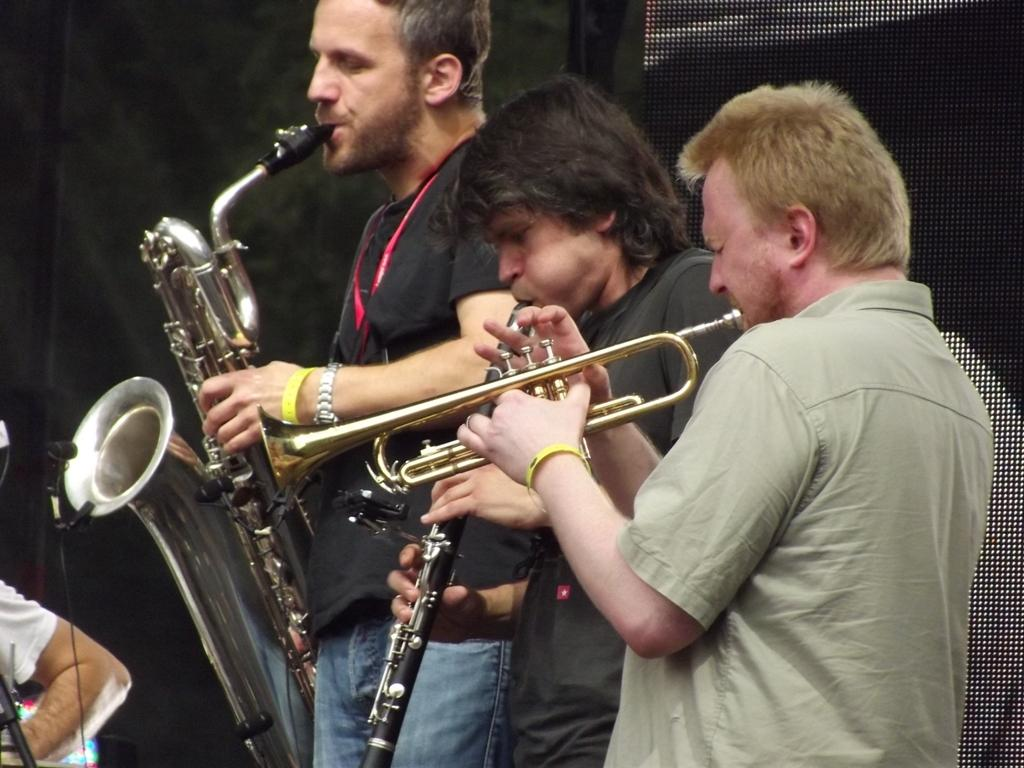How many people are in the image? There are three men in the image. What are the men doing in the image? The men are standing and playing different music instruments. Can you describe the actions of the men in the image? The men are standing and playing music instruments, which suggests they might be in a band or performing. How many horses are visible in the image? There are no horses present in the image. What type of garden can be seen in the background of the image? There is no garden visible in the image. 